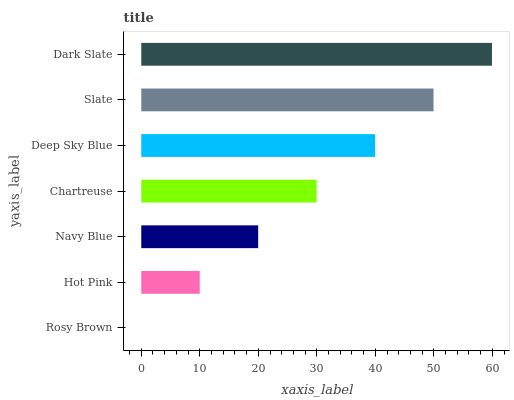Is Rosy Brown the minimum?
Answer yes or no. Yes. Is Dark Slate the maximum?
Answer yes or no. Yes. Is Hot Pink the minimum?
Answer yes or no. No. Is Hot Pink the maximum?
Answer yes or no. No. Is Hot Pink greater than Rosy Brown?
Answer yes or no. Yes. Is Rosy Brown less than Hot Pink?
Answer yes or no. Yes. Is Rosy Brown greater than Hot Pink?
Answer yes or no. No. Is Hot Pink less than Rosy Brown?
Answer yes or no. No. Is Chartreuse the high median?
Answer yes or no. Yes. Is Chartreuse the low median?
Answer yes or no. Yes. Is Rosy Brown the high median?
Answer yes or no. No. Is Navy Blue the low median?
Answer yes or no. No. 